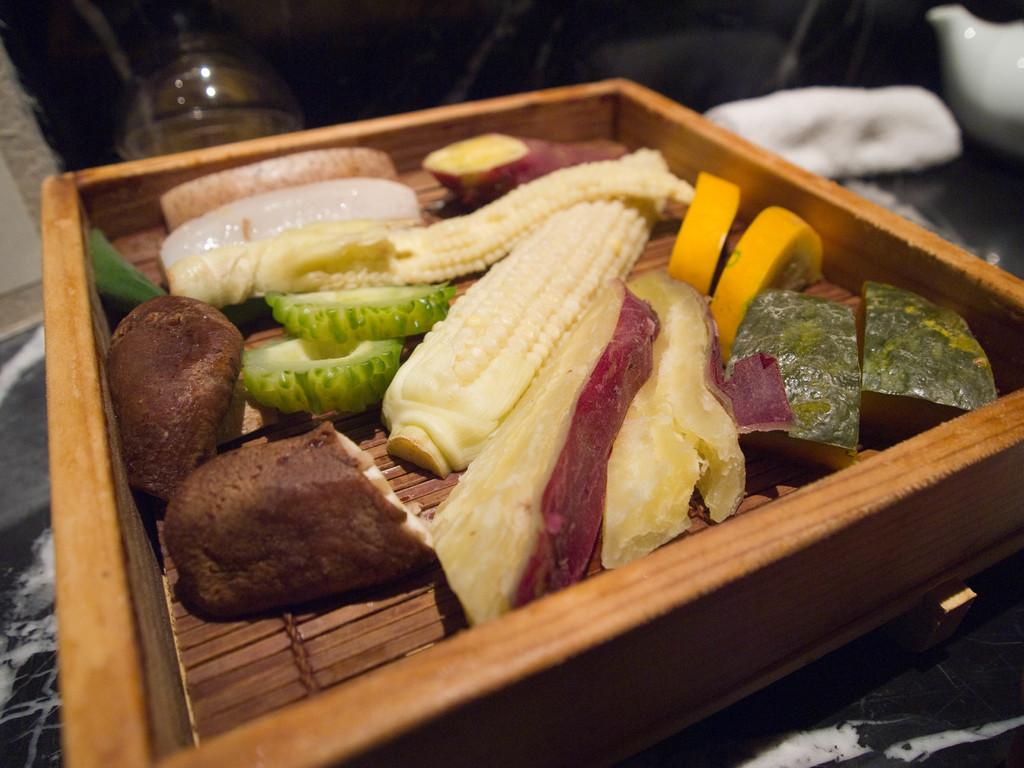What type of food is present in the wooden tray in the image? There are vegetable slices in a wooden tray in the image. Where is the wooden tray located? The wooden tray is on the floor. Can you describe any other objects present in the image? The provided facts do not mention any other objects, so we cannot describe them. How does the cattle contribute to the knowledge in the image? There is no cattle present in the image, so it cannot contribute to any knowledge. 